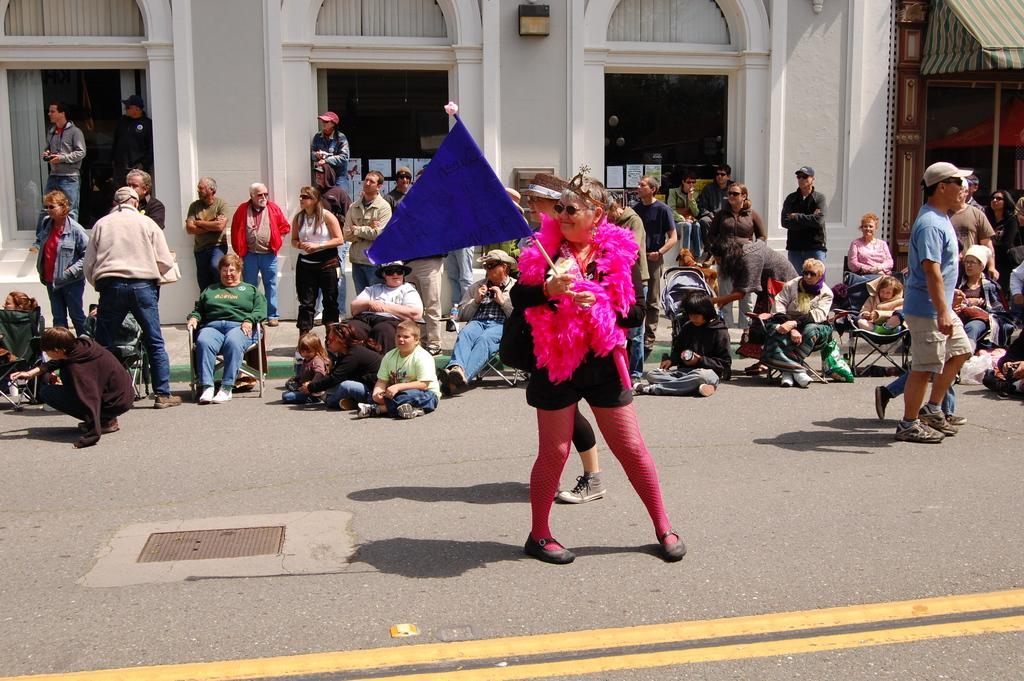What is the person in the center of the image doing? The person is standing on the road and holding a flag. What can be seen in the background of the image? There is a building, a door, and a window visible in the background. Are there any other people in the image besides the person holding the flag? Yes, there are many persons on the road in the background. What type of insurance policy is the bear holding in the image? There is no bear or insurance policy present in the image. Is there any coal visible in the image? There is no coal visible in the image. 